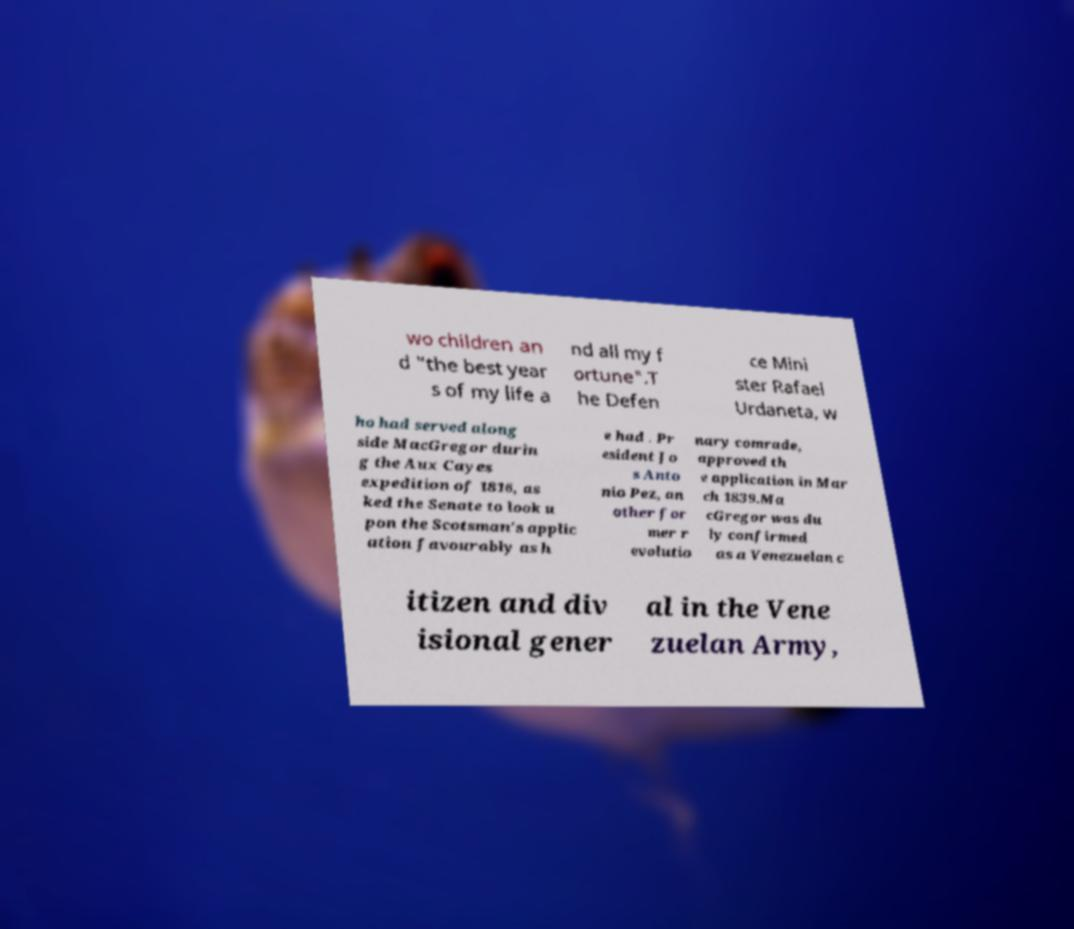For documentation purposes, I need the text within this image transcribed. Could you provide that? wo children an d "the best year s of my life a nd all my f ortune".T he Defen ce Mini ster Rafael Urdaneta, w ho had served along side MacGregor durin g the Aux Cayes expedition of 1816, as ked the Senate to look u pon the Scotsman's applic ation favourably as h e had . Pr esident Jo s Anto nio Pez, an other for mer r evolutio nary comrade, approved th e application in Mar ch 1839.Ma cGregor was du ly confirmed as a Venezuelan c itizen and div isional gener al in the Vene zuelan Army, 